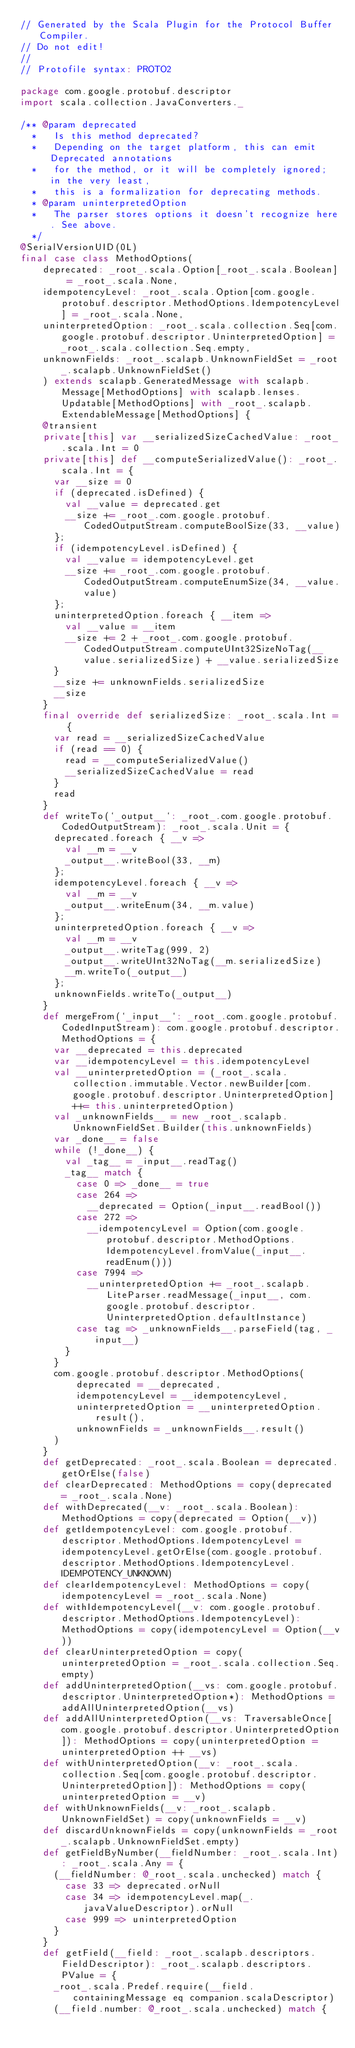<code> <loc_0><loc_0><loc_500><loc_500><_Scala_>// Generated by the Scala Plugin for the Protocol Buffer Compiler.
// Do not edit!
//
// Protofile syntax: PROTO2

package com.google.protobuf.descriptor
import scala.collection.JavaConverters._

/** @param deprecated
  *   Is this method deprecated?
  *   Depending on the target platform, this can emit Deprecated annotations
  *   for the method, or it will be completely ignored; in the very least,
  *   this is a formalization for deprecating methods.
  * @param uninterpretedOption
  *   The parser stores options it doesn't recognize here. See above.
  */
@SerialVersionUID(0L)
final case class MethodOptions(
    deprecated: _root_.scala.Option[_root_.scala.Boolean] = _root_.scala.None,
    idempotencyLevel: _root_.scala.Option[com.google.protobuf.descriptor.MethodOptions.IdempotencyLevel] = _root_.scala.None,
    uninterpretedOption: _root_.scala.collection.Seq[com.google.protobuf.descriptor.UninterpretedOption] = _root_.scala.collection.Seq.empty,
    unknownFields: _root_.scalapb.UnknownFieldSet = _root_.scalapb.UnknownFieldSet()
    ) extends scalapb.GeneratedMessage with scalapb.Message[MethodOptions] with scalapb.lenses.Updatable[MethodOptions] with _root_.scalapb.ExtendableMessage[MethodOptions] {
    @transient
    private[this] var __serializedSizeCachedValue: _root_.scala.Int = 0
    private[this] def __computeSerializedValue(): _root_.scala.Int = {
      var __size = 0
      if (deprecated.isDefined) {
        val __value = deprecated.get
        __size += _root_.com.google.protobuf.CodedOutputStream.computeBoolSize(33, __value)
      };
      if (idempotencyLevel.isDefined) {
        val __value = idempotencyLevel.get
        __size += _root_.com.google.protobuf.CodedOutputStream.computeEnumSize(34, __value.value)
      };
      uninterpretedOption.foreach { __item =>
        val __value = __item
        __size += 2 + _root_.com.google.protobuf.CodedOutputStream.computeUInt32SizeNoTag(__value.serializedSize) + __value.serializedSize
      }
      __size += unknownFields.serializedSize
      __size
    }
    final override def serializedSize: _root_.scala.Int = {
      var read = __serializedSizeCachedValue
      if (read == 0) {
        read = __computeSerializedValue()
        __serializedSizeCachedValue = read
      }
      read
    }
    def writeTo(`_output__`: _root_.com.google.protobuf.CodedOutputStream): _root_.scala.Unit = {
      deprecated.foreach { __v =>
        val __m = __v
        _output__.writeBool(33, __m)
      };
      idempotencyLevel.foreach { __v =>
        val __m = __v
        _output__.writeEnum(34, __m.value)
      };
      uninterpretedOption.foreach { __v =>
        val __m = __v
        _output__.writeTag(999, 2)
        _output__.writeUInt32NoTag(__m.serializedSize)
        __m.writeTo(_output__)
      };
      unknownFields.writeTo(_output__)
    }
    def mergeFrom(`_input__`: _root_.com.google.protobuf.CodedInputStream): com.google.protobuf.descriptor.MethodOptions = {
      var __deprecated = this.deprecated
      var __idempotencyLevel = this.idempotencyLevel
      val __uninterpretedOption = (_root_.scala.collection.immutable.Vector.newBuilder[com.google.protobuf.descriptor.UninterpretedOption] ++= this.uninterpretedOption)
      val _unknownFields__ = new _root_.scalapb.UnknownFieldSet.Builder(this.unknownFields)
      var _done__ = false
      while (!_done__) {
        val _tag__ = _input__.readTag()
        _tag__ match {
          case 0 => _done__ = true
          case 264 =>
            __deprecated = Option(_input__.readBool())
          case 272 =>
            __idempotencyLevel = Option(com.google.protobuf.descriptor.MethodOptions.IdempotencyLevel.fromValue(_input__.readEnum()))
          case 7994 =>
            __uninterpretedOption += _root_.scalapb.LiteParser.readMessage(_input__, com.google.protobuf.descriptor.UninterpretedOption.defaultInstance)
          case tag => _unknownFields__.parseField(tag, _input__)
        }
      }
      com.google.protobuf.descriptor.MethodOptions(
          deprecated = __deprecated,
          idempotencyLevel = __idempotencyLevel,
          uninterpretedOption = __uninterpretedOption.result(),
          unknownFields = _unknownFields__.result()
      )
    }
    def getDeprecated: _root_.scala.Boolean = deprecated.getOrElse(false)
    def clearDeprecated: MethodOptions = copy(deprecated = _root_.scala.None)
    def withDeprecated(__v: _root_.scala.Boolean): MethodOptions = copy(deprecated = Option(__v))
    def getIdempotencyLevel: com.google.protobuf.descriptor.MethodOptions.IdempotencyLevel = idempotencyLevel.getOrElse(com.google.protobuf.descriptor.MethodOptions.IdempotencyLevel.IDEMPOTENCY_UNKNOWN)
    def clearIdempotencyLevel: MethodOptions = copy(idempotencyLevel = _root_.scala.None)
    def withIdempotencyLevel(__v: com.google.protobuf.descriptor.MethodOptions.IdempotencyLevel): MethodOptions = copy(idempotencyLevel = Option(__v))
    def clearUninterpretedOption = copy(uninterpretedOption = _root_.scala.collection.Seq.empty)
    def addUninterpretedOption(__vs: com.google.protobuf.descriptor.UninterpretedOption*): MethodOptions = addAllUninterpretedOption(__vs)
    def addAllUninterpretedOption(__vs: TraversableOnce[com.google.protobuf.descriptor.UninterpretedOption]): MethodOptions = copy(uninterpretedOption = uninterpretedOption ++ __vs)
    def withUninterpretedOption(__v: _root_.scala.collection.Seq[com.google.protobuf.descriptor.UninterpretedOption]): MethodOptions = copy(uninterpretedOption = __v)
    def withUnknownFields(__v: _root_.scalapb.UnknownFieldSet) = copy(unknownFields = __v)
    def discardUnknownFields = copy(unknownFields = _root_.scalapb.UnknownFieldSet.empty)
    def getFieldByNumber(__fieldNumber: _root_.scala.Int): _root_.scala.Any = {
      (__fieldNumber: @_root_.scala.unchecked) match {
        case 33 => deprecated.orNull
        case 34 => idempotencyLevel.map(_.javaValueDescriptor).orNull
        case 999 => uninterpretedOption
      }
    }
    def getField(__field: _root_.scalapb.descriptors.FieldDescriptor): _root_.scalapb.descriptors.PValue = {
      _root_.scala.Predef.require(__field.containingMessage eq companion.scalaDescriptor)
      (__field.number: @_root_.scala.unchecked) match {</code> 